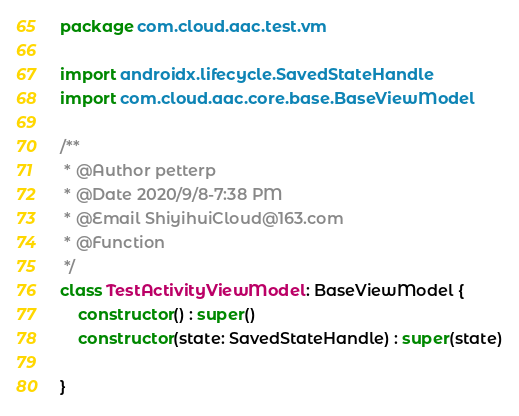<code> <loc_0><loc_0><loc_500><loc_500><_Kotlin_>package com.cloud.aac.test.vm

import androidx.lifecycle.SavedStateHandle
import com.cloud.aac.core.base.BaseViewModel

/**
 * @Author petterp
 * @Date 2020/9/8-7:38 PM
 * @Email ShiyihuiCloud@163.com
 * @Function
 */
class TestActivityViewModel : BaseViewModel {
    constructor() : super()
    constructor(state: SavedStateHandle) : super(state)

}</code> 